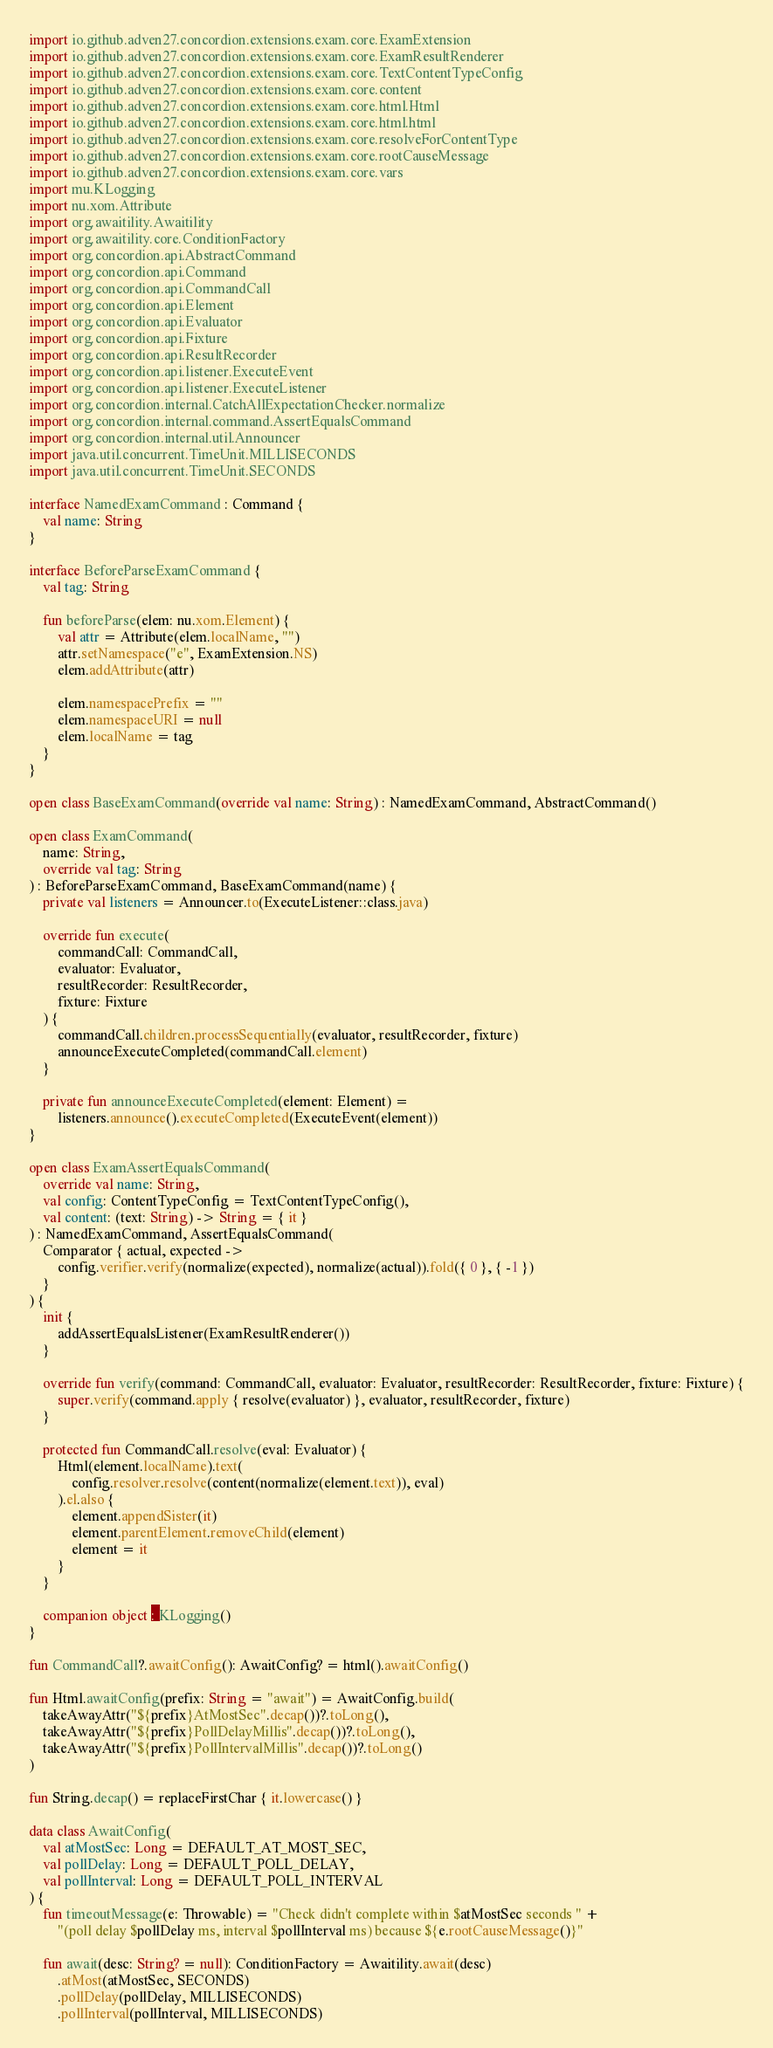<code> <loc_0><loc_0><loc_500><loc_500><_Kotlin_>import io.github.adven27.concordion.extensions.exam.core.ExamExtension
import io.github.adven27.concordion.extensions.exam.core.ExamResultRenderer
import io.github.adven27.concordion.extensions.exam.core.TextContentTypeConfig
import io.github.adven27.concordion.extensions.exam.core.content
import io.github.adven27.concordion.extensions.exam.core.html.Html
import io.github.adven27.concordion.extensions.exam.core.html.html
import io.github.adven27.concordion.extensions.exam.core.resolveForContentType
import io.github.adven27.concordion.extensions.exam.core.rootCauseMessage
import io.github.adven27.concordion.extensions.exam.core.vars
import mu.KLogging
import nu.xom.Attribute
import org.awaitility.Awaitility
import org.awaitility.core.ConditionFactory
import org.concordion.api.AbstractCommand
import org.concordion.api.Command
import org.concordion.api.CommandCall
import org.concordion.api.Element
import org.concordion.api.Evaluator
import org.concordion.api.Fixture
import org.concordion.api.ResultRecorder
import org.concordion.api.listener.ExecuteEvent
import org.concordion.api.listener.ExecuteListener
import org.concordion.internal.CatchAllExpectationChecker.normalize
import org.concordion.internal.command.AssertEqualsCommand
import org.concordion.internal.util.Announcer
import java.util.concurrent.TimeUnit.MILLISECONDS
import java.util.concurrent.TimeUnit.SECONDS

interface NamedExamCommand : Command {
    val name: String
}

interface BeforeParseExamCommand {
    val tag: String

    fun beforeParse(elem: nu.xom.Element) {
        val attr = Attribute(elem.localName, "")
        attr.setNamespace("e", ExamExtension.NS)
        elem.addAttribute(attr)

        elem.namespacePrefix = ""
        elem.namespaceURI = null
        elem.localName = tag
    }
}

open class BaseExamCommand(override val name: String) : NamedExamCommand, AbstractCommand()

open class ExamCommand(
    name: String,
    override val tag: String
) : BeforeParseExamCommand, BaseExamCommand(name) {
    private val listeners = Announcer.to(ExecuteListener::class.java)

    override fun execute(
        commandCall: CommandCall,
        evaluator: Evaluator,
        resultRecorder: ResultRecorder,
        fixture: Fixture
    ) {
        commandCall.children.processSequentially(evaluator, resultRecorder, fixture)
        announceExecuteCompleted(commandCall.element)
    }

    private fun announceExecuteCompleted(element: Element) =
        listeners.announce().executeCompleted(ExecuteEvent(element))
}

open class ExamAssertEqualsCommand(
    override val name: String,
    val config: ContentTypeConfig = TextContentTypeConfig(),
    val content: (text: String) -> String = { it }
) : NamedExamCommand, AssertEqualsCommand(
    Comparator { actual, expected ->
        config.verifier.verify(normalize(expected), normalize(actual)).fold({ 0 }, { -1 })
    }
) {
    init {
        addAssertEqualsListener(ExamResultRenderer())
    }

    override fun verify(command: CommandCall, evaluator: Evaluator, resultRecorder: ResultRecorder, fixture: Fixture) {
        super.verify(command.apply { resolve(evaluator) }, evaluator, resultRecorder, fixture)
    }

    protected fun CommandCall.resolve(eval: Evaluator) {
        Html(element.localName).text(
            config.resolver.resolve(content(normalize(element.text)), eval)
        ).el.also {
            element.appendSister(it)
            element.parentElement.removeChild(element)
            element = it
        }
    }

    companion object : KLogging()
}

fun CommandCall?.awaitConfig(): AwaitConfig? = html().awaitConfig()

fun Html.awaitConfig(prefix: String = "await") = AwaitConfig.build(
    takeAwayAttr("${prefix}AtMostSec".decap())?.toLong(),
    takeAwayAttr("${prefix}PollDelayMillis".decap())?.toLong(),
    takeAwayAttr("${prefix}PollIntervalMillis".decap())?.toLong()
)

fun String.decap() = replaceFirstChar { it.lowercase() }

data class AwaitConfig(
    val atMostSec: Long = DEFAULT_AT_MOST_SEC,
    val pollDelay: Long = DEFAULT_POLL_DELAY,
    val pollInterval: Long = DEFAULT_POLL_INTERVAL
) {
    fun timeoutMessage(e: Throwable) = "Check didn't complete within $atMostSec seconds " +
        "(poll delay $pollDelay ms, interval $pollInterval ms) because ${e.rootCauseMessage()}"

    fun await(desc: String? = null): ConditionFactory = Awaitility.await(desc)
        .atMost(atMostSec, SECONDS)
        .pollDelay(pollDelay, MILLISECONDS)
        .pollInterval(pollInterval, MILLISECONDS)
</code> 